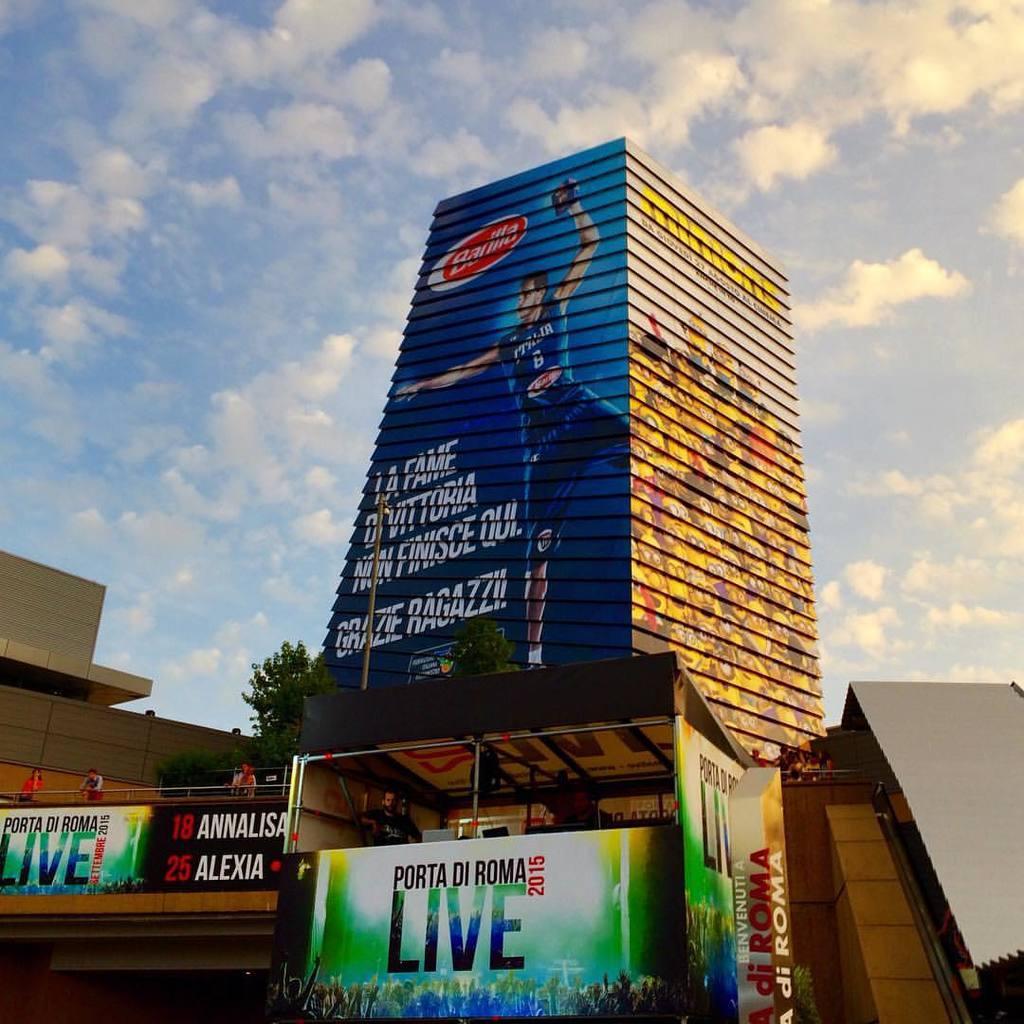In one or two sentences, can you explain what this image depicts? At the bottom of the picture, we see a food truck in black, white, green, yellow and blue color. On the right side, we see a building in grey color. On the left side, we see a bridge and the people are standing. We see a banner in white, black, yellow, green and blue color with some text written on it. There are trees, buildings and a pole in the background. At the top, we see the sky and the clouds. 